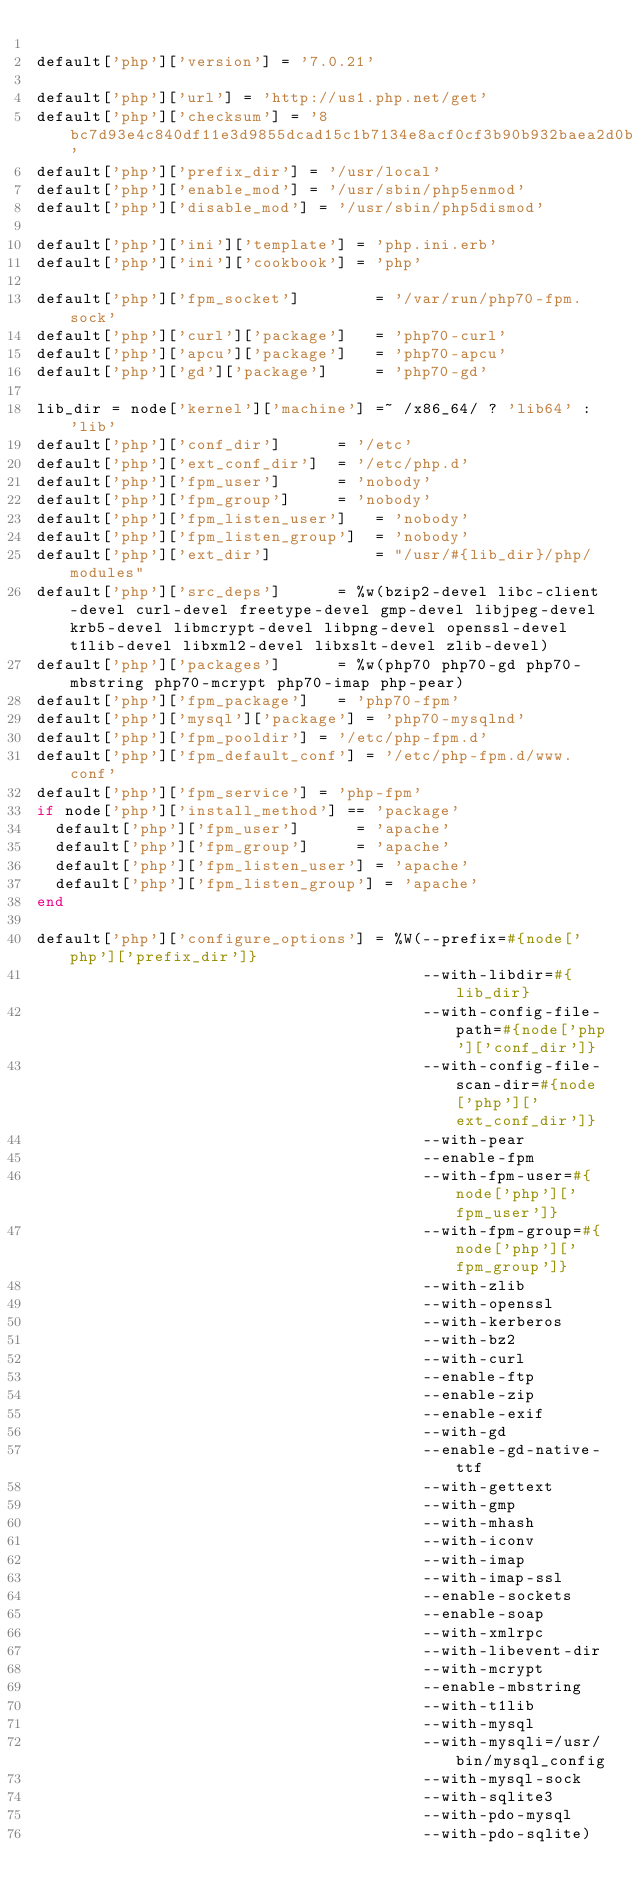Convert code to text. <code><loc_0><loc_0><loc_500><loc_500><_Ruby_>
default['php']['version'] = '7.0.21'

default['php']['url'] = 'http://us1.php.net/get'
default['php']['checksum'] = '8bc7d93e4c840df11e3d9855dcad15c1b7134e8acf0cf3b90b932baea2d0bde2'
default['php']['prefix_dir'] = '/usr/local'
default['php']['enable_mod'] = '/usr/sbin/php5enmod'
default['php']['disable_mod'] = '/usr/sbin/php5dismod'

default['php']['ini']['template'] = 'php.ini.erb'
default['php']['ini']['cookbook'] = 'php'

default['php']['fpm_socket']        = '/var/run/php70-fpm.sock'
default['php']['curl']['package']   = 'php70-curl'
default['php']['apcu']['package']   = 'php70-apcu'
default['php']['gd']['package']     = 'php70-gd'

lib_dir = node['kernel']['machine'] =~ /x86_64/ ? 'lib64' : 'lib'
default['php']['conf_dir']      = '/etc'
default['php']['ext_conf_dir']  = '/etc/php.d'
default['php']['fpm_user']      = 'nobody'
default['php']['fpm_group']     = 'nobody'
default['php']['fpm_listen_user']   = 'nobody'
default['php']['fpm_listen_group']  = 'nobody'
default['php']['ext_dir']           = "/usr/#{lib_dir}/php/modules"
default['php']['src_deps']      = %w(bzip2-devel libc-client-devel curl-devel freetype-devel gmp-devel libjpeg-devel krb5-devel libmcrypt-devel libpng-devel openssl-devel t1lib-devel libxml2-devel libxslt-devel zlib-devel)
default['php']['packages']      = %w(php70 php70-gd php70-mbstring php70-mcrypt php70-imap php-pear)
default['php']['fpm_package']   = 'php70-fpm'
default['php']['mysql']['package'] = 'php70-mysqlnd'
default['php']['fpm_pooldir'] = '/etc/php-fpm.d'
default['php']['fpm_default_conf'] = '/etc/php-fpm.d/www.conf'
default['php']['fpm_service'] = 'php-fpm'
if node['php']['install_method'] == 'package'
  default['php']['fpm_user']      = 'apache'
  default['php']['fpm_group']     = 'apache'
  default['php']['fpm_listen_user'] = 'apache'
  default['php']['fpm_listen_group'] = 'apache'
end

default['php']['configure_options'] = %W(--prefix=#{node['php']['prefix_dir']}
                                         --with-libdir=#{lib_dir}
                                         --with-config-file-path=#{node['php']['conf_dir']}
                                         --with-config-file-scan-dir=#{node['php']['ext_conf_dir']}
                                         --with-pear
                                         --enable-fpm
                                         --with-fpm-user=#{node['php']['fpm_user']}
                                         --with-fpm-group=#{node['php']['fpm_group']}
                                         --with-zlib
                                         --with-openssl
                                         --with-kerberos
                                         --with-bz2
                                         --with-curl
                                         --enable-ftp
                                         --enable-zip
                                         --enable-exif
                                         --with-gd
                                         --enable-gd-native-ttf
                                         --with-gettext
                                         --with-gmp
                                         --with-mhash
                                         --with-iconv
                                         --with-imap
                                         --with-imap-ssl
                                         --enable-sockets
                                         --enable-soap
                                         --with-xmlrpc
                                         --with-libevent-dir
                                         --with-mcrypt
                                         --enable-mbstring
                                         --with-t1lib
                                         --with-mysql
                                         --with-mysqli=/usr/bin/mysql_config
                                         --with-mysql-sock
                                         --with-sqlite3
                                         --with-pdo-mysql
                                         --with-pdo-sqlite)
</code> 